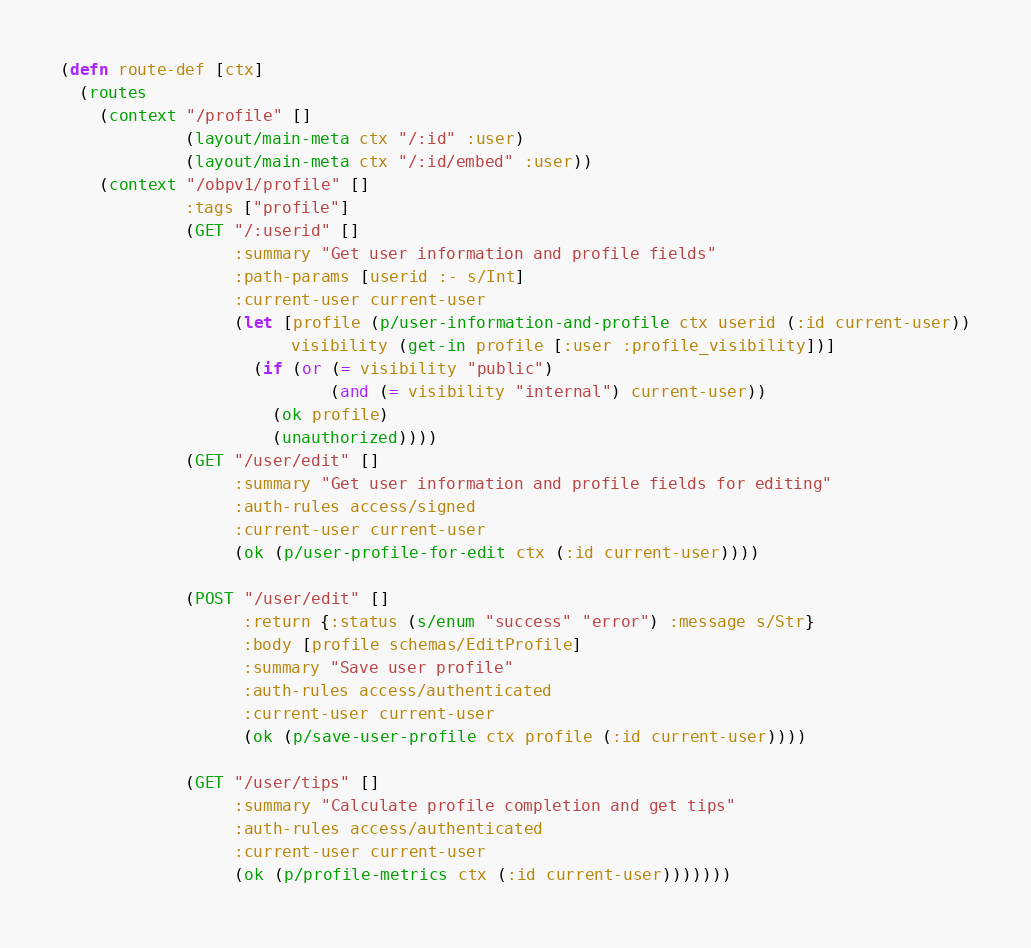<code> <loc_0><loc_0><loc_500><loc_500><_Clojure_>(defn route-def [ctx]
  (routes
    (context "/profile" []
             (layout/main-meta ctx "/:id" :user)
             (layout/main-meta ctx "/:id/embed" :user))
    (context "/obpv1/profile" []
             :tags ["profile"]
             (GET "/:userid" []
                  :summary "Get user information and profile fields"
                  :path-params [userid :- s/Int]
                  :current-user current-user
                  (let [profile (p/user-information-and-profile ctx userid (:id current-user))
                        visibility (get-in profile [:user :profile_visibility])]
                    (if (or (= visibility "public")
                            (and (= visibility "internal") current-user))
                      (ok profile)
                      (unauthorized))))
             (GET "/user/edit" []
                  :summary "Get user information and profile fields for editing"
                  :auth-rules access/signed
                  :current-user current-user
                  (ok (p/user-profile-for-edit ctx (:id current-user))))

             (POST "/user/edit" []
                   :return {:status (s/enum "success" "error") :message s/Str}
                   :body [profile schemas/EditProfile]
                   :summary "Save user profile"
                   :auth-rules access/authenticated
                   :current-user current-user
                   (ok (p/save-user-profile ctx profile (:id current-user))))

             (GET "/user/tips" []
                  :summary "Calculate profile completion and get tips"
                  :auth-rules access/authenticated
                  :current-user current-user
                  (ok (p/profile-metrics ctx (:id current-user)))))))
</code> 